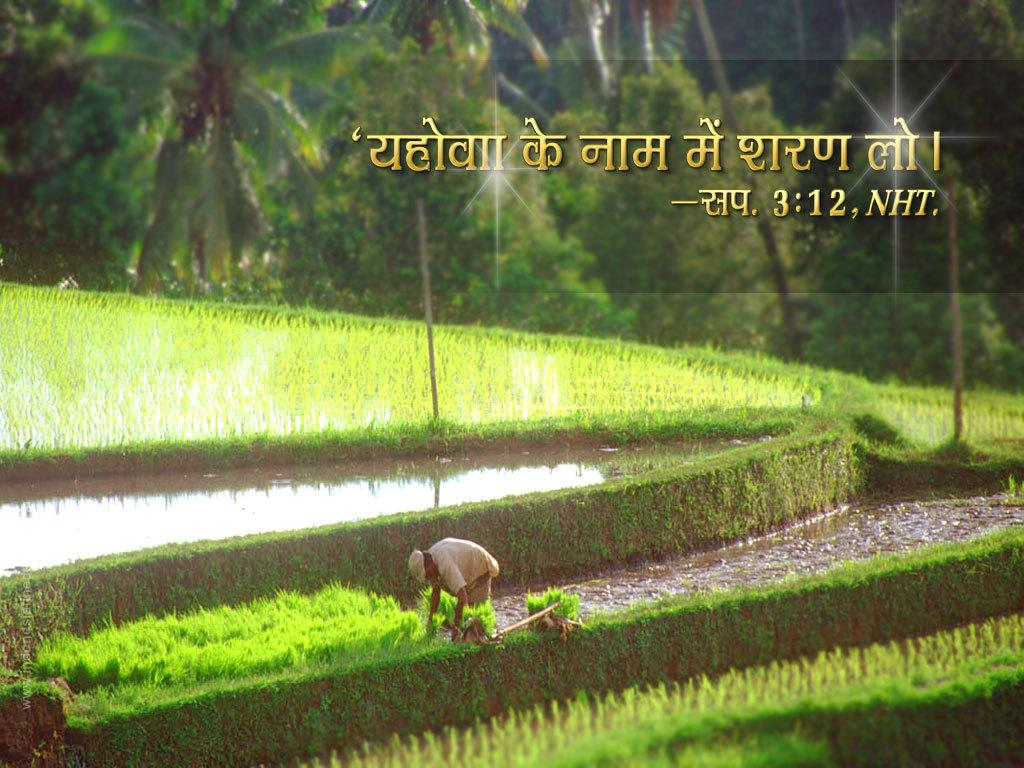What is the main setting of the image? The image consists of fields. What can be seen in the middle of the fields? There is water in the middle of the image. Is there anyone present in the image? Yes, there is a person at the bottom of the image. What is visible at the top of the image? There are trees at the top of the image, and there is something written there as well. What type of fight is taking place between the trees in the image? There is no fight taking place between the trees in the image; they are simply trees in the background. 